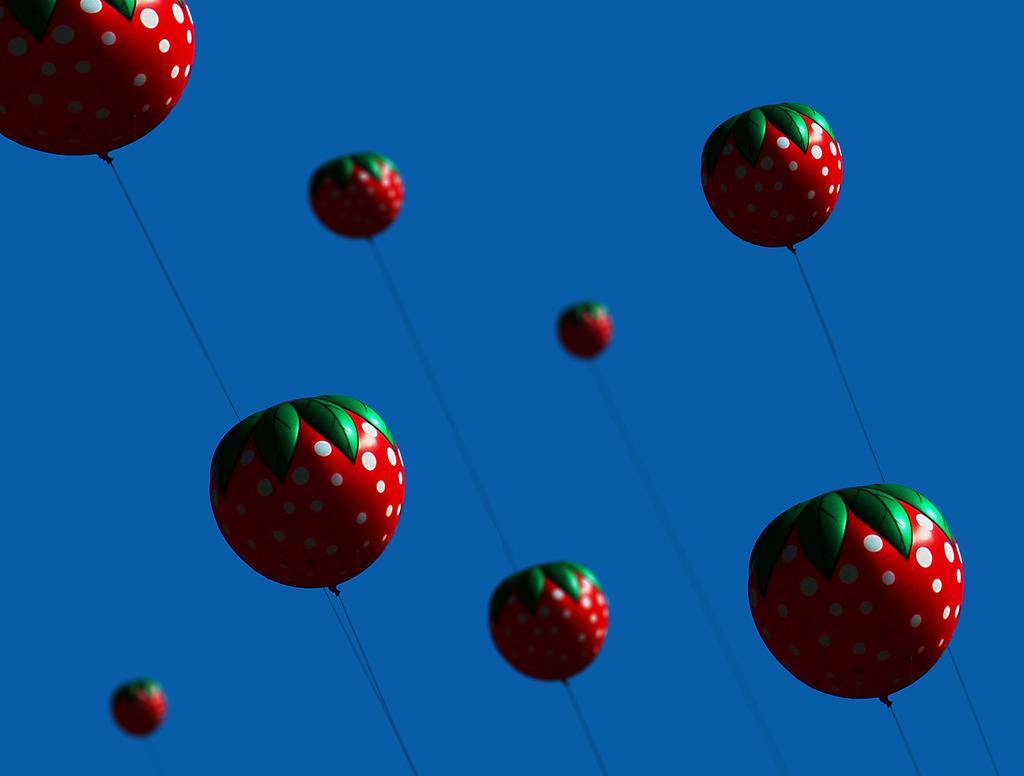How would you summarize this image in a sentence or two? In this picture, we see balloons are flying in the sky. These balloons are in red and green color. These balloons look like strawberries. In the background, we see the sky, which is blue in color. 